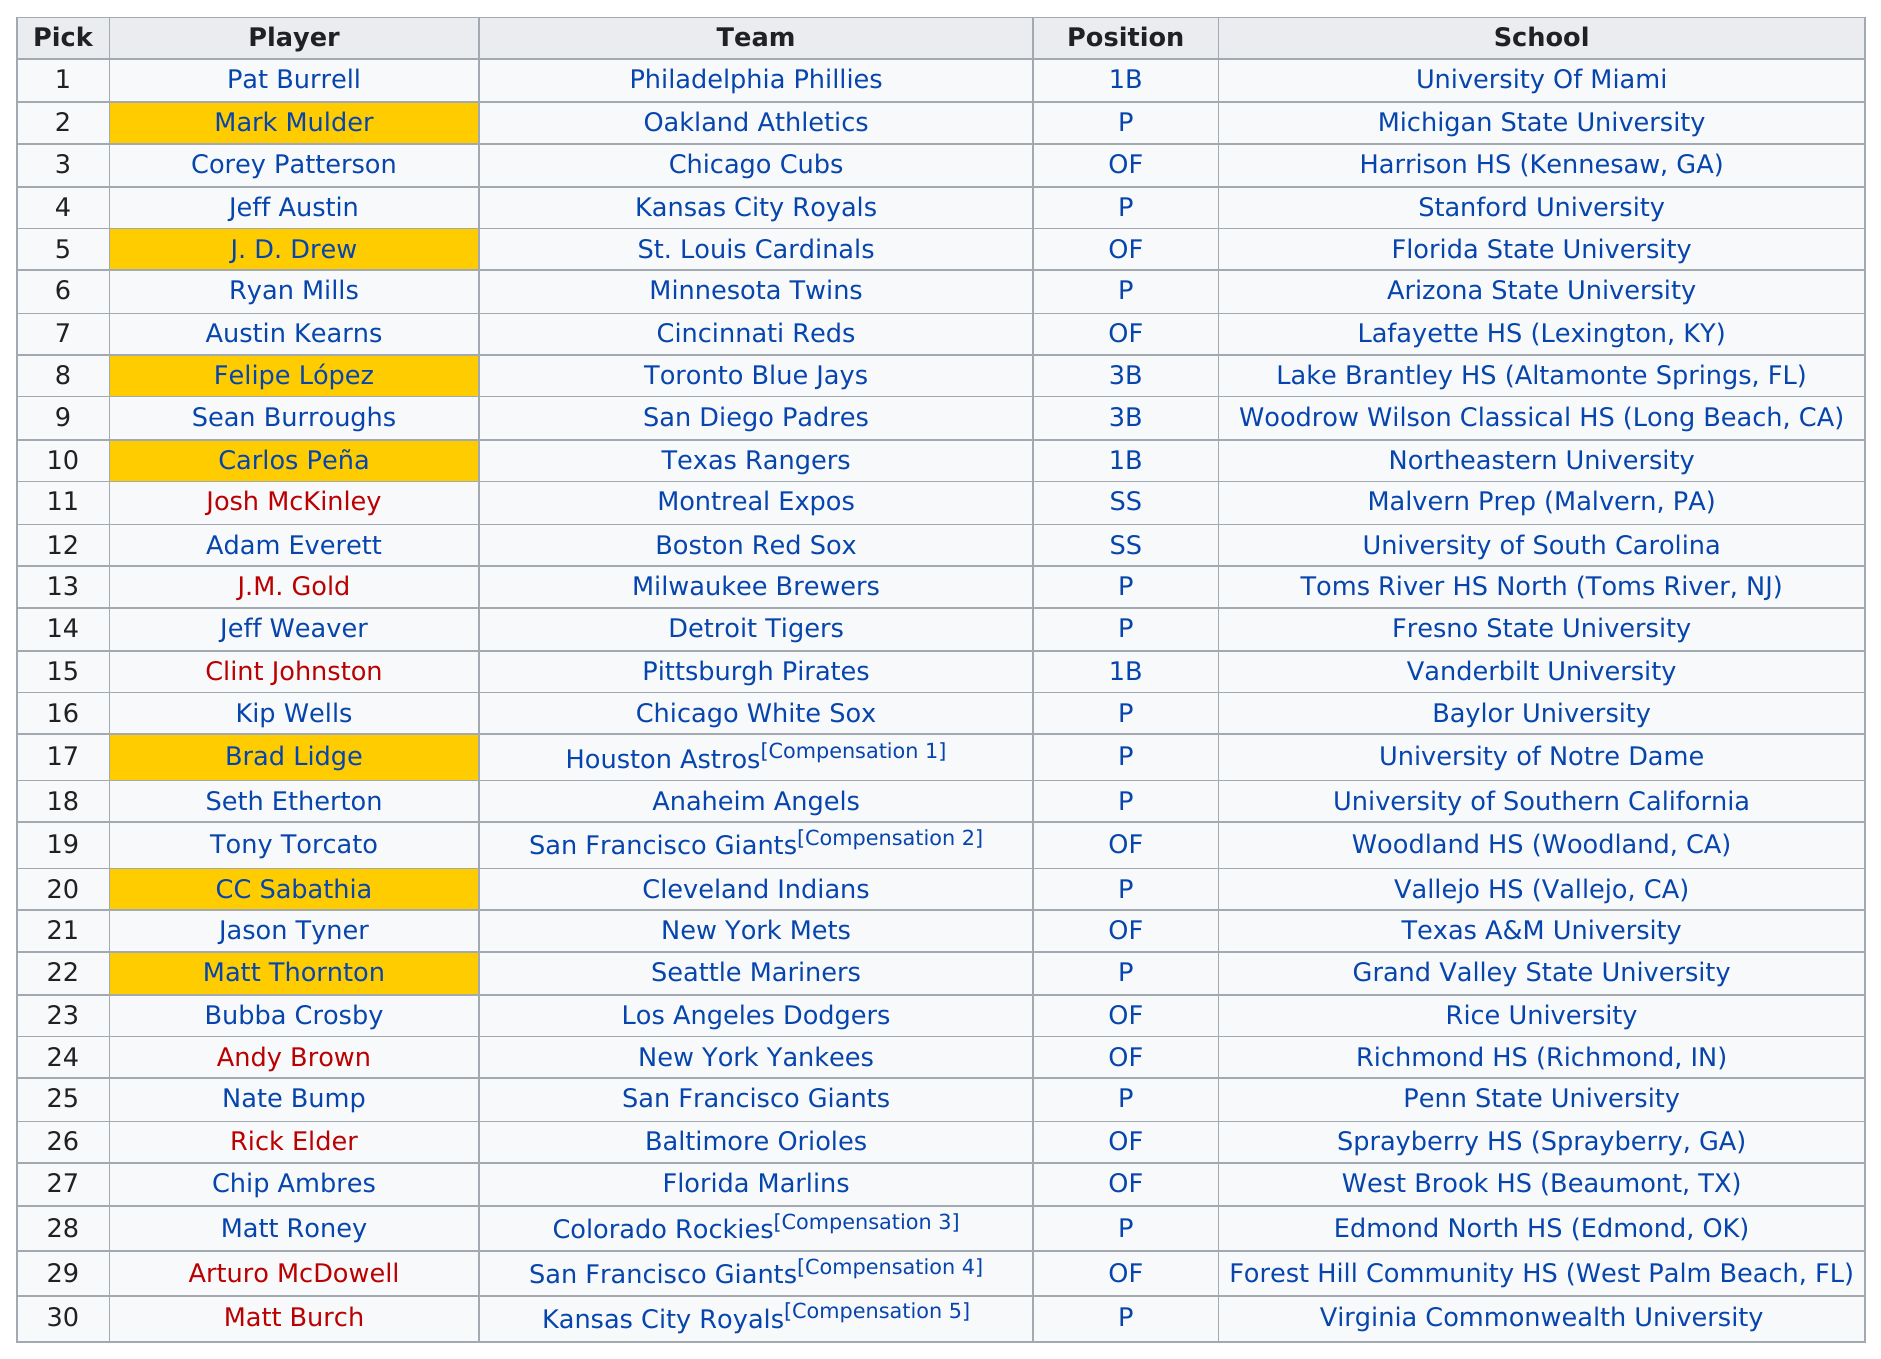Indicate a few pertinent items in this graphic. Mark Mulder played in the Major League Baseball for the Oakland Athletics. Mark Mulder is listed after Pat Burrell in a particular order. In the table, Austin Kearns is preceded by Ryan Mills. Ryan Mills played for the Minnesota Twins, but Sean Burroughs played for the San Diego Padres. Mark Mulder was the top pitcher who was drafted. 